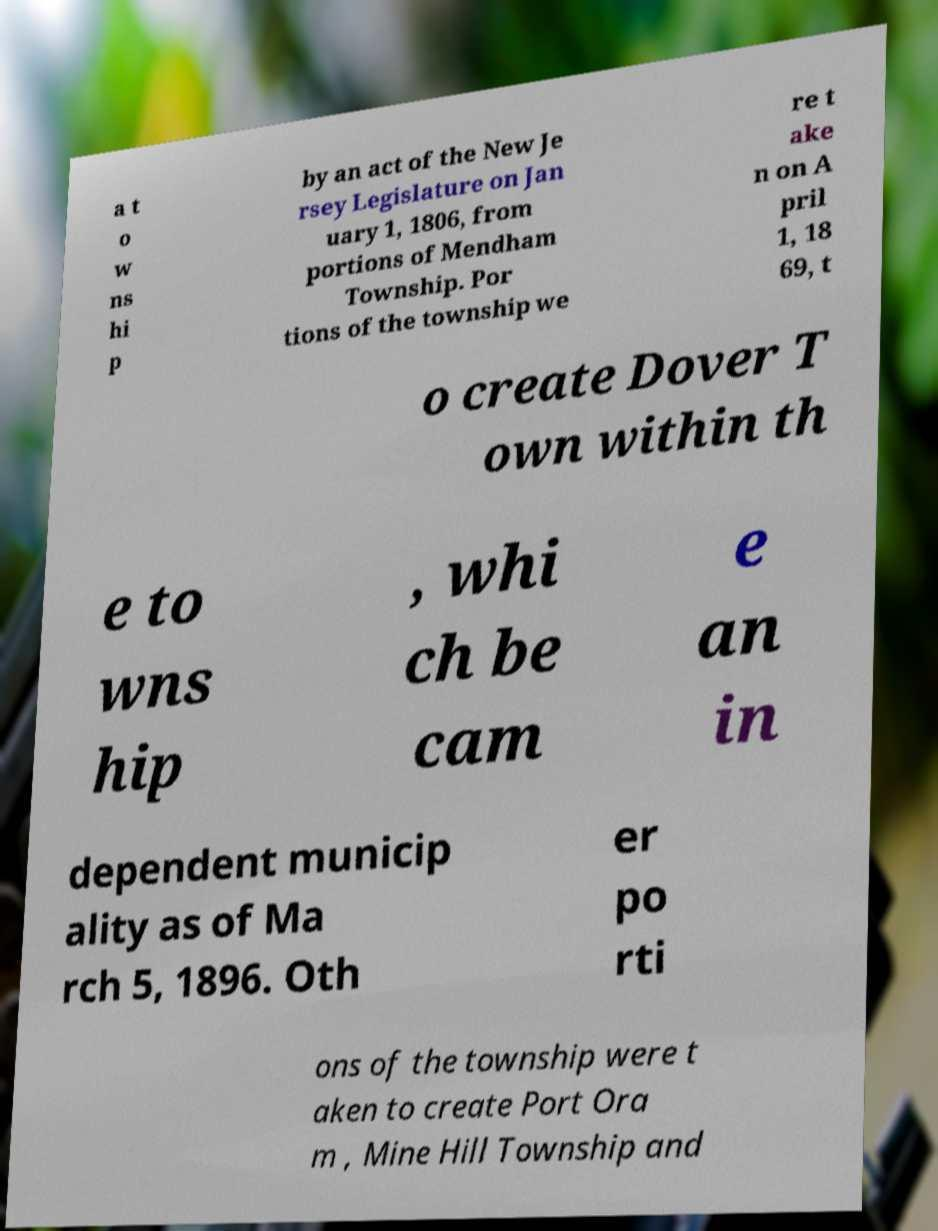Could you assist in decoding the text presented in this image and type it out clearly? a t o w ns hi p by an act of the New Je rsey Legislature on Jan uary 1, 1806, from portions of Mendham Township. Por tions of the township we re t ake n on A pril 1, 18 69, t o create Dover T own within th e to wns hip , whi ch be cam e an in dependent municip ality as of Ma rch 5, 1896. Oth er po rti ons of the township were t aken to create Port Ora m , Mine Hill Township and 